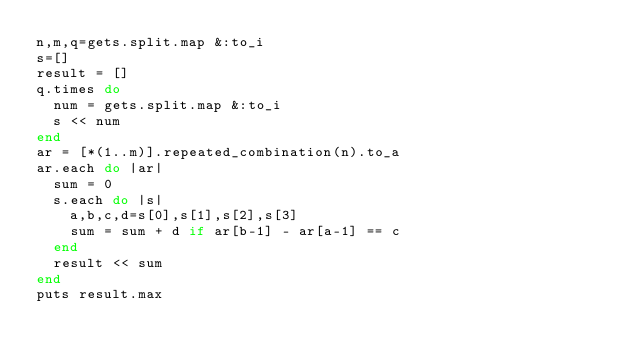Convert code to text. <code><loc_0><loc_0><loc_500><loc_500><_Ruby_>n,m,q=gets.split.map &:to_i
s=[]
result = []
q.times do
  num = gets.split.map &:to_i
  s << num
end
ar = [*(1..m)].repeated_combination(n).to_a
ar.each do |ar|
  sum = 0
  s.each do |s|
    a,b,c,d=s[0],s[1],s[2],s[3]
    sum = sum + d if ar[b-1] - ar[a-1] == c
  end
  result << sum
end
puts result.max</code> 